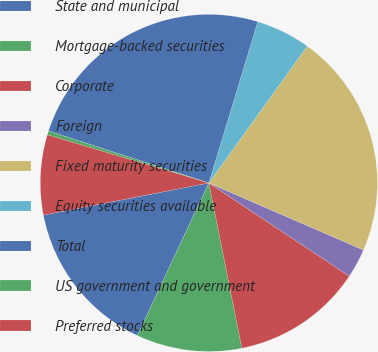Convert chart. <chart><loc_0><loc_0><loc_500><loc_500><pie_chart><fcel>State and municipal<fcel>Mortgage-backed securities<fcel>Corporate<fcel>Foreign<fcel>Fixed maturity securities<fcel>Equity securities available<fcel>Total<fcel>US government and government<fcel>Preferred stocks<nl><fcel>14.97%<fcel>10.11%<fcel>12.54%<fcel>2.81%<fcel>21.59%<fcel>5.24%<fcel>24.7%<fcel>0.38%<fcel>7.67%<nl></chart> 